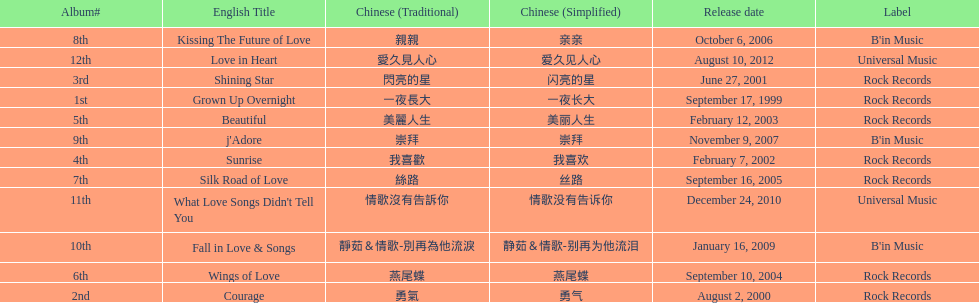What label was she working with before universal music? B'in Music. Can you give me this table as a dict? {'header': ['Album#', 'English Title', 'Chinese (Traditional)', 'Chinese (Simplified)', 'Release date', 'Label'], 'rows': [['8th', 'Kissing The Future of Love', '親親', '亲亲', 'October 6, 2006', "B'in Music"], ['12th', 'Love in Heart', '愛久見人心', '爱久见人心', 'August 10, 2012', 'Universal Music'], ['3rd', 'Shining Star', '閃亮的星', '闪亮的星', 'June 27, 2001', 'Rock Records'], ['1st', 'Grown Up Overnight', '一夜長大', '一夜长大', 'September 17, 1999', 'Rock Records'], ['5th', 'Beautiful', '美麗人生', '美丽人生', 'February 12, 2003', 'Rock Records'], ['9th', "j'Adore", '崇拜', '崇拜', 'November 9, 2007', "B'in Music"], ['4th', 'Sunrise', '我喜歡', '我喜欢', 'February 7, 2002', 'Rock Records'], ['7th', 'Silk Road of Love', '絲路', '丝路', 'September 16, 2005', 'Rock Records'], ['11th', "What Love Songs Didn't Tell You", '情歌沒有告訴你', '情歌没有告诉你', 'December 24, 2010', 'Universal Music'], ['10th', 'Fall in Love & Songs', '靜茹＆情歌-別再為他流淚', '静茹＆情歌-别再为他流泪', 'January 16, 2009', "B'in Music"], ['6th', 'Wings of Love', '燕尾蝶', '燕尾蝶', 'September 10, 2004', 'Rock Records'], ['2nd', 'Courage', '勇氣', '勇气', 'August 2, 2000', 'Rock Records']]} 